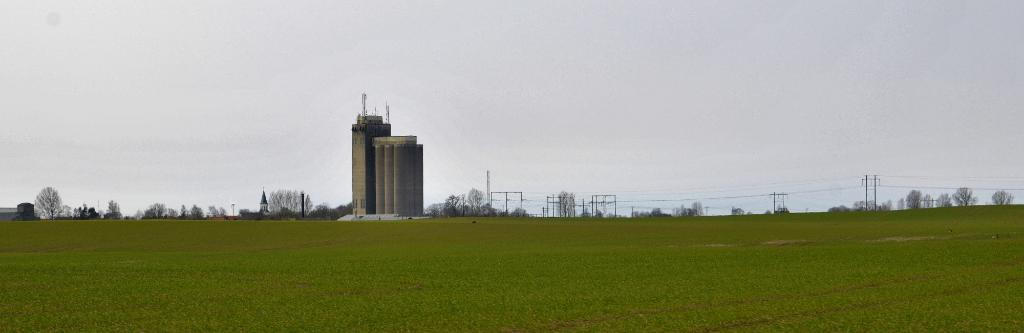What type of vegetation is present in the image? There is grass in the image, and trees are also visible. What color are the grass and trees in the image? The grass and trees are green. What can be seen in the background of the image? There is a building and electric poles in the background of the image. What colors are used for the building in the image? The building is gray and white. What is the color of the sky in the image? The sky is white in the image. What type of property is being celebrated during the spring feast in the image? There is no property or feast present in the image; it features grass, trees, a building, electric poles, and a white sky. 